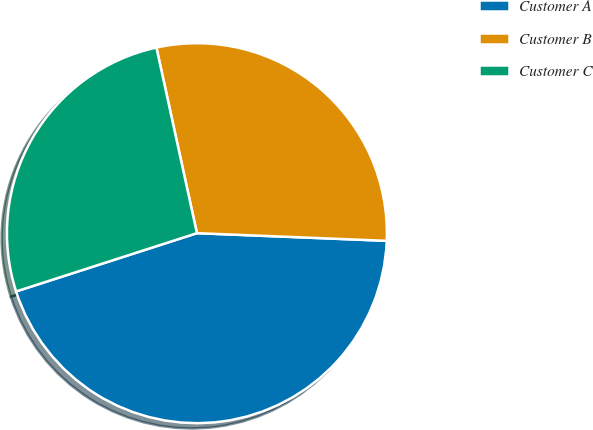Convert chart. <chart><loc_0><loc_0><loc_500><loc_500><pie_chart><fcel>Customer A<fcel>Customer B<fcel>Customer C<nl><fcel>44.39%<fcel>29.06%<fcel>26.54%<nl></chart> 